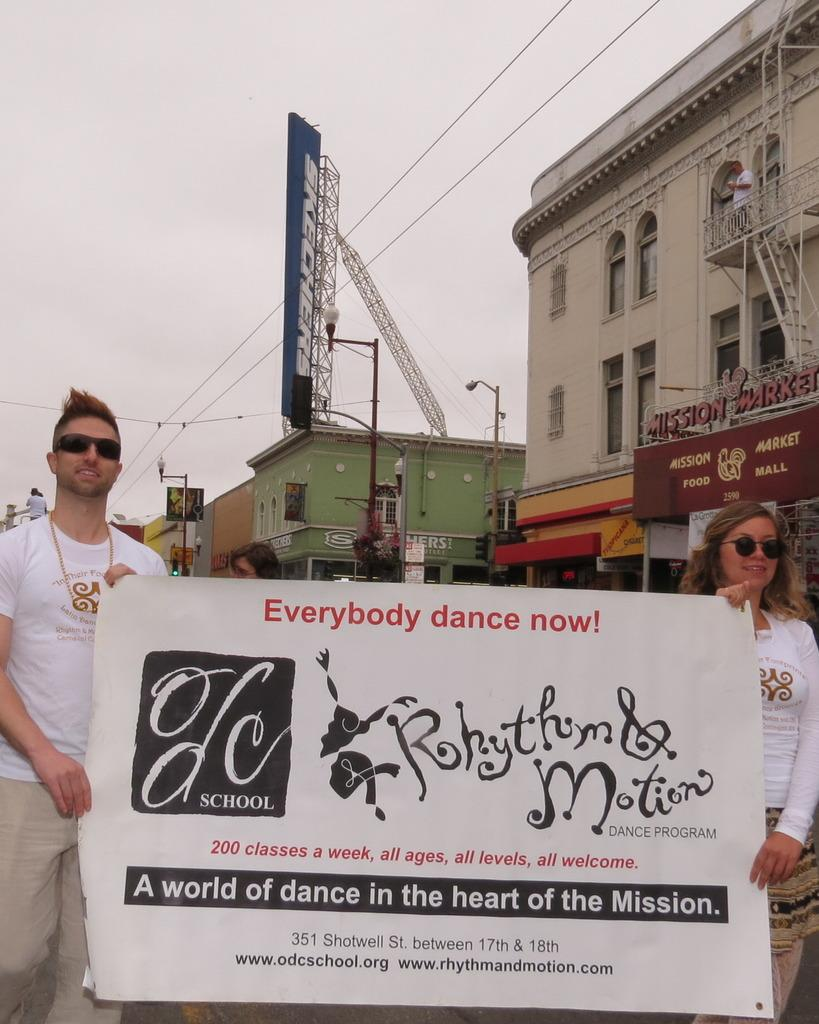What are the two people in the image doing? The two people are holding a banner in the image. What can be seen in the background of the image? There are many buildings and stores in the background of the image. What part of the natural environment is visible in the image? The sky is visible in the background of the image. What type of quartz can be seen in the image? There is no quartz present in the image. What brand of jeans are the people wearing in the image? The image does not show the clothing of the people, so it cannot be determined what type of jeans they might be wearing. 